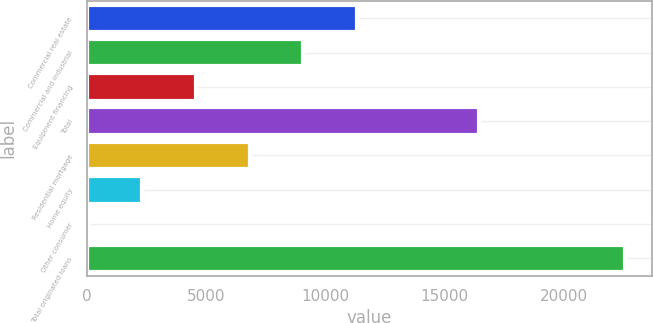Convert chart to OTSL. <chart><loc_0><loc_0><loc_500><loc_500><bar_chart><fcel>Commercial real estate<fcel>Commercial and industrial<fcel>Equipment financing<fcel>Total<fcel>Residential mortgage<fcel>Home equity<fcel>Other consumer<fcel>Total originated loans<nl><fcel>11314.2<fcel>9065.14<fcel>4566.92<fcel>16451.5<fcel>6816.03<fcel>2317.81<fcel>68.7<fcel>22559.8<nl></chart> 